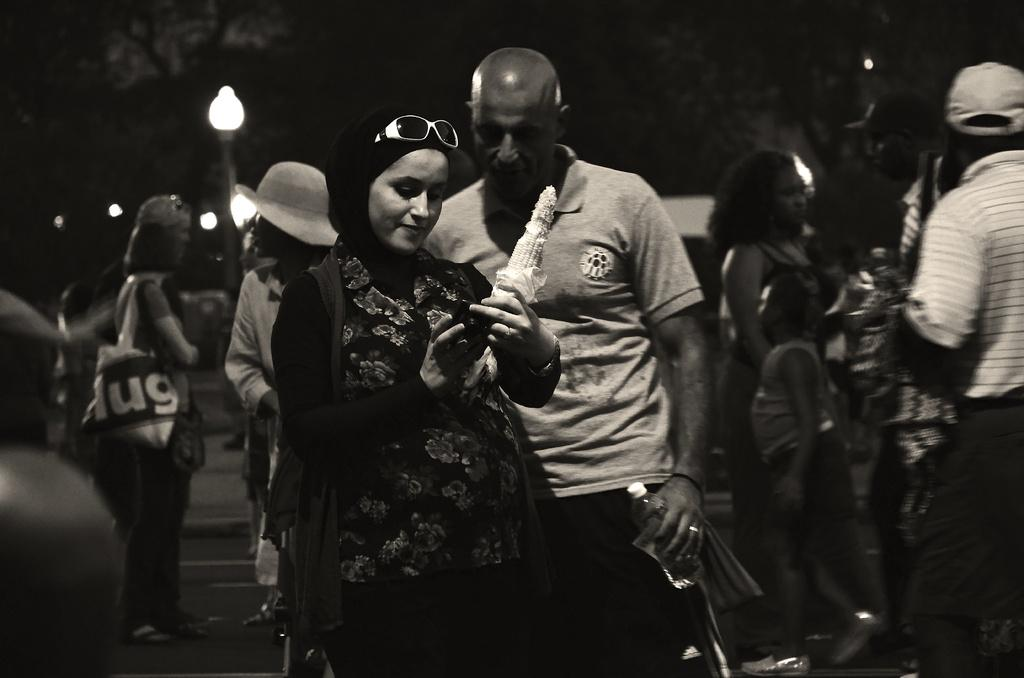What are the people in the image doing? The group of people is standing on the road. What can be seen in the image besides the people? There are lights, a bottle, bags, caps, goggles, and sweet corn visible in the image. What is the color of the background in the image? The background of the image is dark. What type of design can be seen on the tongue of the person in the image? There is no person's tongue visible in the image. What color is the boot worn by the person in the image? There is no person wearing a boot in the image. 